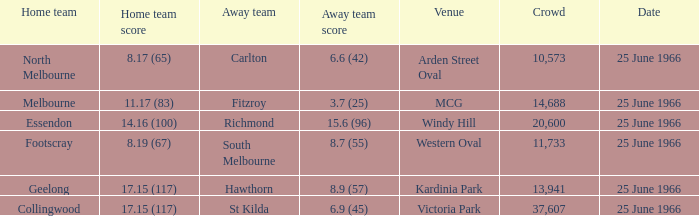Help me parse the entirety of this table. {'header': ['Home team', 'Home team score', 'Away team', 'Away team score', 'Venue', 'Crowd', 'Date'], 'rows': [['North Melbourne', '8.17 (65)', 'Carlton', '6.6 (42)', 'Arden Street Oval', '10,573', '25 June 1966'], ['Melbourne', '11.17 (83)', 'Fitzroy', '3.7 (25)', 'MCG', '14,688', '25 June 1966'], ['Essendon', '14.16 (100)', 'Richmond', '15.6 (96)', 'Windy Hill', '20,600', '25 June 1966'], ['Footscray', '8.19 (67)', 'South Melbourne', '8.7 (55)', 'Western Oval', '11,733', '25 June 1966'], ['Geelong', '17.15 (117)', 'Hawthorn', '8.9 (57)', 'Kardinia Park', '13,941', '25 June 1966'], ['Collingwood', '17.15 (117)', 'St Kilda', '6.9 (45)', 'Victoria Park', '37,607', '25 June 1966']]} What is the total crowd size when a home team scored 17.15 (117) versus hawthorn? 13941.0. 